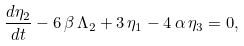Convert formula to latex. <formula><loc_0><loc_0><loc_500><loc_500>\frac { d \eta _ { 2 } } { d t } - 6 \, \beta \, \Lambda _ { 2 } + 3 \, \eta _ { 1 } - 4 \, \alpha \, \eta _ { 3 } = 0 ,</formula> 